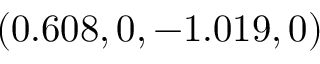Convert formula to latex. <formula><loc_0><loc_0><loc_500><loc_500>( 0 . 6 0 8 , 0 , - 1 . 0 1 9 , 0 )</formula> 